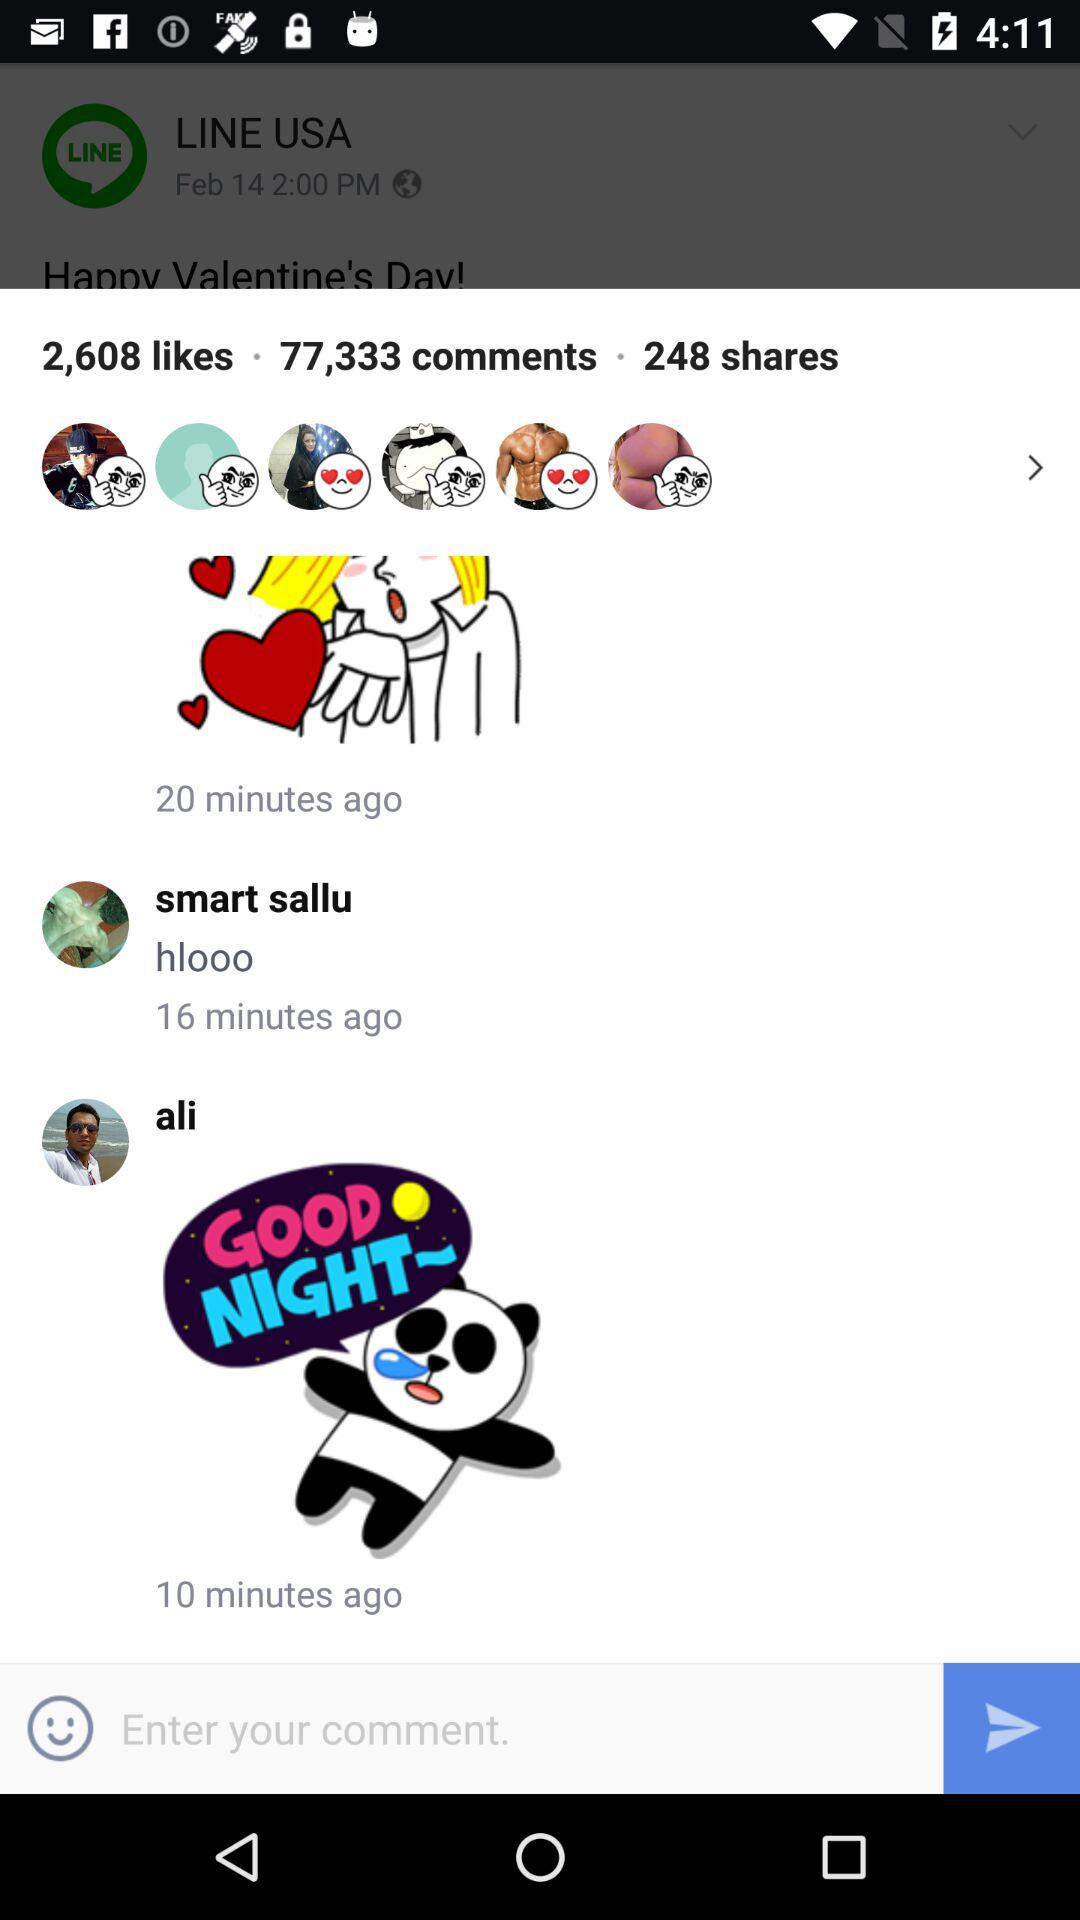What is the time when Ali comments? Ali commented 10 minutes ago. 